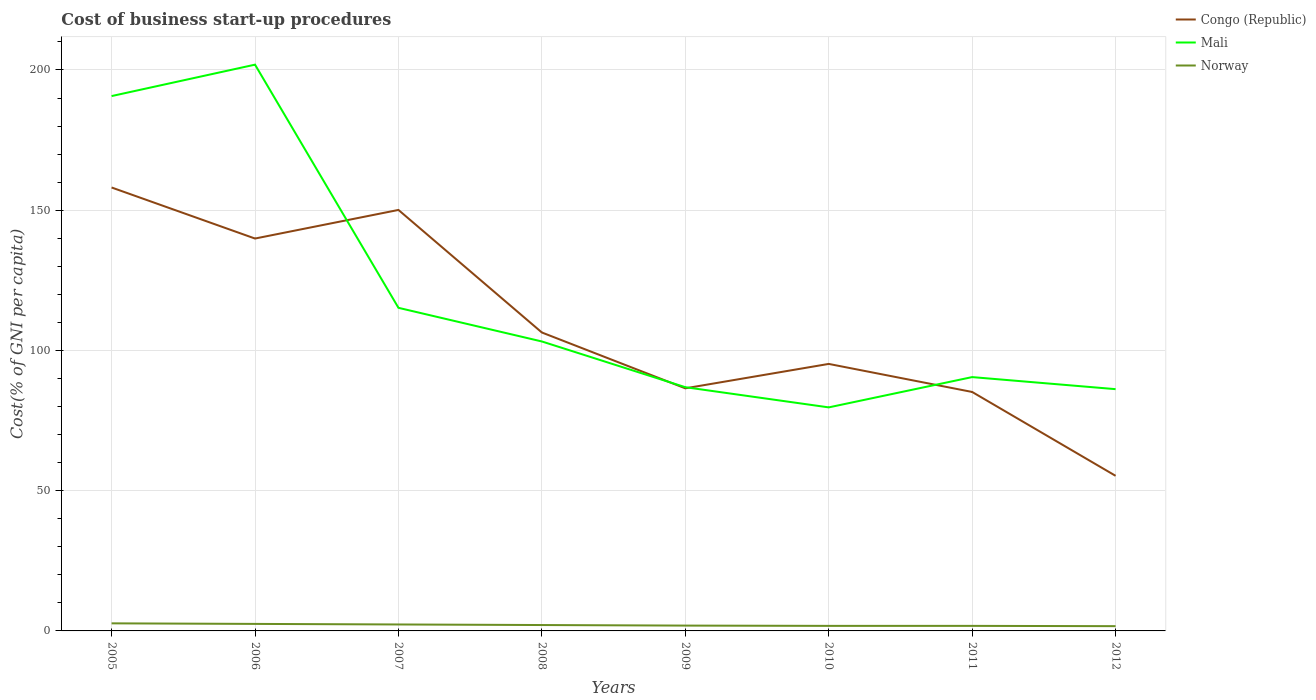Across all years, what is the maximum cost of business start-up procedures in Norway?
Provide a short and direct response. 1.7. In which year was the cost of business start-up procedures in Norway maximum?
Your answer should be very brief. 2012. What is the total cost of business start-up procedures in Mali in the graph?
Ensure brevity in your answer.  103.8. What is the difference between the highest and the second highest cost of business start-up procedures in Congo (Republic)?
Ensure brevity in your answer.  102.8. How many lines are there?
Keep it short and to the point. 3. Where does the legend appear in the graph?
Your answer should be compact. Top right. How are the legend labels stacked?
Provide a succinct answer. Vertical. What is the title of the graph?
Offer a very short reply. Cost of business start-up procedures. Does "Sao Tome and Principe" appear as one of the legend labels in the graph?
Ensure brevity in your answer.  No. What is the label or title of the X-axis?
Provide a short and direct response. Years. What is the label or title of the Y-axis?
Make the answer very short. Cost(% of GNI per capita). What is the Cost(% of GNI per capita) in Congo (Republic) in 2005?
Your response must be concise. 158.1. What is the Cost(% of GNI per capita) in Mali in 2005?
Your response must be concise. 190.7. What is the Cost(% of GNI per capita) of Norway in 2005?
Your answer should be very brief. 2.7. What is the Cost(% of GNI per capita) in Congo (Republic) in 2006?
Your answer should be compact. 139.9. What is the Cost(% of GNI per capita) of Mali in 2006?
Offer a very short reply. 201.9. What is the Cost(% of GNI per capita) of Norway in 2006?
Your response must be concise. 2.5. What is the Cost(% of GNI per capita) of Congo (Republic) in 2007?
Make the answer very short. 150.1. What is the Cost(% of GNI per capita) of Mali in 2007?
Make the answer very short. 115.2. What is the Cost(% of GNI per capita) in Norway in 2007?
Give a very brief answer. 2.3. What is the Cost(% of GNI per capita) in Congo (Republic) in 2008?
Your answer should be very brief. 106.4. What is the Cost(% of GNI per capita) in Mali in 2008?
Your answer should be compact. 103.2. What is the Cost(% of GNI per capita) of Norway in 2008?
Provide a succinct answer. 2.1. What is the Cost(% of GNI per capita) of Congo (Republic) in 2009?
Your response must be concise. 86.5. What is the Cost(% of GNI per capita) of Mali in 2009?
Provide a succinct answer. 86.9. What is the Cost(% of GNI per capita) of Congo (Republic) in 2010?
Your answer should be very brief. 95.2. What is the Cost(% of GNI per capita) of Mali in 2010?
Ensure brevity in your answer.  79.7. What is the Cost(% of GNI per capita) of Congo (Republic) in 2011?
Provide a succinct answer. 85.2. What is the Cost(% of GNI per capita) in Mali in 2011?
Provide a short and direct response. 90.5. What is the Cost(% of GNI per capita) of Congo (Republic) in 2012?
Keep it short and to the point. 55.3. What is the Cost(% of GNI per capita) of Mali in 2012?
Offer a very short reply. 86.2. What is the Cost(% of GNI per capita) of Norway in 2012?
Provide a short and direct response. 1.7. Across all years, what is the maximum Cost(% of GNI per capita) in Congo (Republic)?
Give a very brief answer. 158.1. Across all years, what is the maximum Cost(% of GNI per capita) in Mali?
Your response must be concise. 201.9. Across all years, what is the maximum Cost(% of GNI per capita) in Norway?
Provide a short and direct response. 2.7. Across all years, what is the minimum Cost(% of GNI per capita) in Congo (Republic)?
Provide a succinct answer. 55.3. Across all years, what is the minimum Cost(% of GNI per capita) in Mali?
Provide a short and direct response. 79.7. Across all years, what is the minimum Cost(% of GNI per capita) in Norway?
Provide a short and direct response. 1.7. What is the total Cost(% of GNI per capita) of Congo (Republic) in the graph?
Ensure brevity in your answer.  876.7. What is the total Cost(% of GNI per capita) of Mali in the graph?
Your answer should be very brief. 954.3. What is the total Cost(% of GNI per capita) of Norway in the graph?
Your response must be concise. 16.8. What is the difference between the Cost(% of GNI per capita) of Congo (Republic) in 2005 and that in 2006?
Offer a very short reply. 18.2. What is the difference between the Cost(% of GNI per capita) of Norway in 2005 and that in 2006?
Offer a very short reply. 0.2. What is the difference between the Cost(% of GNI per capita) in Congo (Republic) in 2005 and that in 2007?
Make the answer very short. 8. What is the difference between the Cost(% of GNI per capita) in Mali in 2005 and that in 2007?
Provide a succinct answer. 75.5. What is the difference between the Cost(% of GNI per capita) of Norway in 2005 and that in 2007?
Your answer should be very brief. 0.4. What is the difference between the Cost(% of GNI per capita) of Congo (Republic) in 2005 and that in 2008?
Keep it short and to the point. 51.7. What is the difference between the Cost(% of GNI per capita) of Mali in 2005 and that in 2008?
Your response must be concise. 87.5. What is the difference between the Cost(% of GNI per capita) of Congo (Republic) in 2005 and that in 2009?
Your answer should be compact. 71.6. What is the difference between the Cost(% of GNI per capita) in Mali in 2005 and that in 2009?
Offer a very short reply. 103.8. What is the difference between the Cost(% of GNI per capita) in Norway in 2005 and that in 2009?
Give a very brief answer. 0.8. What is the difference between the Cost(% of GNI per capita) in Congo (Republic) in 2005 and that in 2010?
Provide a succinct answer. 62.9. What is the difference between the Cost(% of GNI per capita) of Mali in 2005 and that in 2010?
Keep it short and to the point. 111. What is the difference between the Cost(% of GNI per capita) of Norway in 2005 and that in 2010?
Your response must be concise. 0.9. What is the difference between the Cost(% of GNI per capita) in Congo (Republic) in 2005 and that in 2011?
Your response must be concise. 72.9. What is the difference between the Cost(% of GNI per capita) of Mali in 2005 and that in 2011?
Provide a succinct answer. 100.2. What is the difference between the Cost(% of GNI per capita) of Congo (Republic) in 2005 and that in 2012?
Your answer should be very brief. 102.8. What is the difference between the Cost(% of GNI per capita) in Mali in 2005 and that in 2012?
Offer a very short reply. 104.5. What is the difference between the Cost(% of GNI per capita) of Mali in 2006 and that in 2007?
Your response must be concise. 86.7. What is the difference between the Cost(% of GNI per capita) of Norway in 2006 and that in 2007?
Offer a terse response. 0.2. What is the difference between the Cost(% of GNI per capita) of Congo (Republic) in 2006 and that in 2008?
Give a very brief answer. 33.5. What is the difference between the Cost(% of GNI per capita) of Mali in 2006 and that in 2008?
Your answer should be compact. 98.7. What is the difference between the Cost(% of GNI per capita) of Congo (Republic) in 2006 and that in 2009?
Your response must be concise. 53.4. What is the difference between the Cost(% of GNI per capita) in Mali in 2006 and that in 2009?
Give a very brief answer. 115. What is the difference between the Cost(% of GNI per capita) of Congo (Republic) in 2006 and that in 2010?
Offer a very short reply. 44.7. What is the difference between the Cost(% of GNI per capita) in Mali in 2006 and that in 2010?
Offer a very short reply. 122.2. What is the difference between the Cost(% of GNI per capita) in Norway in 2006 and that in 2010?
Offer a terse response. 0.7. What is the difference between the Cost(% of GNI per capita) in Congo (Republic) in 2006 and that in 2011?
Make the answer very short. 54.7. What is the difference between the Cost(% of GNI per capita) of Mali in 2006 and that in 2011?
Offer a very short reply. 111.4. What is the difference between the Cost(% of GNI per capita) in Congo (Republic) in 2006 and that in 2012?
Your response must be concise. 84.6. What is the difference between the Cost(% of GNI per capita) of Mali in 2006 and that in 2012?
Offer a terse response. 115.7. What is the difference between the Cost(% of GNI per capita) in Norway in 2006 and that in 2012?
Offer a very short reply. 0.8. What is the difference between the Cost(% of GNI per capita) in Congo (Republic) in 2007 and that in 2008?
Provide a short and direct response. 43.7. What is the difference between the Cost(% of GNI per capita) in Congo (Republic) in 2007 and that in 2009?
Your answer should be compact. 63.6. What is the difference between the Cost(% of GNI per capita) in Mali in 2007 and that in 2009?
Your answer should be compact. 28.3. What is the difference between the Cost(% of GNI per capita) of Norway in 2007 and that in 2009?
Ensure brevity in your answer.  0.4. What is the difference between the Cost(% of GNI per capita) in Congo (Republic) in 2007 and that in 2010?
Your response must be concise. 54.9. What is the difference between the Cost(% of GNI per capita) in Mali in 2007 and that in 2010?
Provide a short and direct response. 35.5. What is the difference between the Cost(% of GNI per capita) in Norway in 2007 and that in 2010?
Provide a succinct answer. 0.5. What is the difference between the Cost(% of GNI per capita) of Congo (Republic) in 2007 and that in 2011?
Your answer should be very brief. 64.9. What is the difference between the Cost(% of GNI per capita) in Mali in 2007 and that in 2011?
Ensure brevity in your answer.  24.7. What is the difference between the Cost(% of GNI per capita) in Congo (Republic) in 2007 and that in 2012?
Keep it short and to the point. 94.8. What is the difference between the Cost(% of GNI per capita) in Mali in 2007 and that in 2012?
Your answer should be compact. 29. What is the difference between the Cost(% of GNI per capita) of Mali in 2008 and that in 2009?
Your answer should be compact. 16.3. What is the difference between the Cost(% of GNI per capita) in Norway in 2008 and that in 2009?
Give a very brief answer. 0.2. What is the difference between the Cost(% of GNI per capita) in Congo (Republic) in 2008 and that in 2010?
Provide a succinct answer. 11.2. What is the difference between the Cost(% of GNI per capita) of Mali in 2008 and that in 2010?
Keep it short and to the point. 23.5. What is the difference between the Cost(% of GNI per capita) of Congo (Republic) in 2008 and that in 2011?
Offer a terse response. 21.2. What is the difference between the Cost(% of GNI per capita) of Mali in 2008 and that in 2011?
Your response must be concise. 12.7. What is the difference between the Cost(% of GNI per capita) in Norway in 2008 and that in 2011?
Give a very brief answer. 0.3. What is the difference between the Cost(% of GNI per capita) of Congo (Republic) in 2008 and that in 2012?
Offer a terse response. 51.1. What is the difference between the Cost(% of GNI per capita) of Norway in 2008 and that in 2012?
Offer a terse response. 0.4. What is the difference between the Cost(% of GNI per capita) of Mali in 2009 and that in 2010?
Make the answer very short. 7.2. What is the difference between the Cost(% of GNI per capita) of Congo (Republic) in 2009 and that in 2011?
Ensure brevity in your answer.  1.3. What is the difference between the Cost(% of GNI per capita) of Mali in 2009 and that in 2011?
Offer a very short reply. -3.6. What is the difference between the Cost(% of GNI per capita) in Norway in 2009 and that in 2011?
Your answer should be very brief. 0.1. What is the difference between the Cost(% of GNI per capita) in Congo (Republic) in 2009 and that in 2012?
Keep it short and to the point. 31.2. What is the difference between the Cost(% of GNI per capita) of Mali in 2009 and that in 2012?
Your answer should be very brief. 0.7. What is the difference between the Cost(% of GNI per capita) in Norway in 2009 and that in 2012?
Your answer should be very brief. 0.2. What is the difference between the Cost(% of GNI per capita) in Congo (Republic) in 2010 and that in 2011?
Keep it short and to the point. 10. What is the difference between the Cost(% of GNI per capita) in Norway in 2010 and that in 2011?
Ensure brevity in your answer.  0. What is the difference between the Cost(% of GNI per capita) in Congo (Republic) in 2010 and that in 2012?
Make the answer very short. 39.9. What is the difference between the Cost(% of GNI per capita) in Congo (Republic) in 2011 and that in 2012?
Keep it short and to the point. 29.9. What is the difference between the Cost(% of GNI per capita) of Mali in 2011 and that in 2012?
Ensure brevity in your answer.  4.3. What is the difference between the Cost(% of GNI per capita) of Norway in 2011 and that in 2012?
Your answer should be compact. 0.1. What is the difference between the Cost(% of GNI per capita) of Congo (Republic) in 2005 and the Cost(% of GNI per capita) of Mali in 2006?
Your response must be concise. -43.8. What is the difference between the Cost(% of GNI per capita) in Congo (Republic) in 2005 and the Cost(% of GNI per capita) in Norway in 2006?
Provide a short and direct response. 155.6. What is the difference between the Cost(% of GNI per capita) in Mali in 2005 and the Cost(% of GNI per capita) in Norway in 2006?
Provide a succinct answer. 188.2. What is the difference between the Cost(% of GNI per capita) in Congo (Republic) in 2005 and the Cost(% of GNI per capita) in Mali in 2007?
Make the answer very short. 42.9. What is the difference between the Cost(% of GNI per capita) in Congo (Republic) in 2005 and the Cost(% of GNI per capita) in Norway in 2007?
Offer a terse response. 155.8. What is the difference between the Cost(% of GNI per capita) of Mali in 2005 and the Cost(% of GNI per capita) of Norway in 2007?
Keep it short and to the point. 188.4. What is the difference between the Cost(% of GNI per capita) in Congo (Republic) in 2005 and the Cost(% of GNI per capita) in Mali in 2008?
Provide a succinct answer. 54.9. What is the difference between the Cost(% of GNI per capita) in Congo (Republic) in 2005 and the Cost(% of GNI per capita) in Norway in 2008?
Provide a succinct answer. 156. What is the difference between the Cost(% of GNI per capita) of Mali in 2005 and the Cost(% of GNI per capita) of Norway in 2008?
Ensure brevity in your answer.  188.6. What is the difference between the Cost(% of GNI per capita) in Congo (Republic) in 2005 and the Cost(% of GNI per capita) in Mali in 2009?
Make the answer very short. 71.2. What is the difference between the Cost(% of GNI per capita) in Congo (Republic) in 2005 and the Cost(% of GNI per capita) in Norway in 2009?
Make the answer very short. 156.2. What is the difference between the Cost(% of GNI per capita) in Mali in 2005 and the Cost(% of GNI per capita) in Norway in 2009?
Keep it short and to the point. 188.8. What is the difference between the Cost(% of GNI per capita) in Congo (Republic) in 2005 and the Cost(% of GNI per capita) in Mali in 2010?
Make the answer very short. 78.4. What is the difference between the Cost(% of GNI per capita) of Congo (Republic) in 2005 and the Cost(% of GNI per capita) of Norway in 2010?
Make the answer very short. 156.3. What is the difference between the Cost(% of GNI per capita) in Mali in 2005 and the Cost(% of GNI per capita) in Norway in 2010?
Provide a succinct answer. 188.9. What is the difference between the Cost(% of GNI per capita) in Congo (Republic) in 2005 and the Cost(% of GNI per capita) in Mali in 2011?
Offer a terse response. 67.6. What is the difference between the Cost(% of GNI per capita) in Congo (Republic) in 2005 and the Cost(% of GNI per capita) in Norway in 2011?
Provide a short and direct response. 156.3. What is the difference between the Cost(% of GNI per capita) in Mali in 2005 and the Cost(% of GNI per capita) in Norway in 2011?
Provide a short and direct response. 188.9. What is the difference between the Cost(% of GNI per capita) in Congo (Republic) in 2005 and the Cost(% of GNI per capita) in Mali in 2012?
Your answer should be very brief. 71.9. What is the difference between the Cost(% of GNI per capita) in Congo (Republic) in 2005 and the Cost(% of GNI per capita) in Norway in 2012?
Offer a very short reply. 156.4. What is the difference between the Cost(% of GNI per capita) of Mali in 2005 and the Cost(% of GNI per capita) of Norway in 2012?
Give a very brief answer. 189. What is the difference between the Cost(% of GNI per capita) of Congo (Republic) in 2006 and the Cost(% of GNI per capita) of Mali in 2007?
Your response must be concise. 24.7. What is the difference between the Cost(% of GNI per capita) in Congo (Republic) in 2006 and the Cost(% of GNI per capita) in Norway in 2007?
Keep it short and to the point. 137.6. What is the difference between the Cost(% of GNI per capita) in Mali in 2006 and the Cost(% of GNI per capita) in Norway in 2007?
Your response must be concise. 199.6. What is the difference between the Cost(% of GNI per capita) in Congo (Republic) in 2006 and the Cost(% of GNI per capita) in Mali in 2008?
Offer a terse response. 36.7. What is the difference between the Cost(% of GNI per capita) in Congo (Republic) in 2006 and the Cost(% of GNI per capita) in Norway in 2008?
Provide a short and direct response. 137.8. What is the difference between the Cost(% of GNI per capita) of Mali in 2006 and the Cost(% of GNI per capita) of Norway in 2008?
Ensure brevity in your answer.  199.8. What is the difference between the Cost(% of GNI per capita) of Congo (Republic) in 2006 and the Cost(% of GNI per capita) of Norway in 2009?
Your answer should be compact. 138. What is the difference between the Cost(% of GNI per capita) in Congo (Republic) in 2006 and the Cost(% of GNI per capita) in Mali in 2010?
Your answer should be very brief. 60.2. What is the difference between the Cost(% of GNI per capita) of Congo (Republic) in 2006 and the Cost(% of GNI per capita) of Norway in 2010?
Give a very brief answer. 138.1. What is the difference between the Cost(% of GNI per capita) of Mali in 2006 and the Cost(% of GNI per capita) of Norway in 2010?
Give a very brief answer. 200.1. What is the difference between the Cost(% of GNI per capita) in Congo (Republic) in 2006 and the Cost(% of GNI per capita) in Mali in 2011?
Your response must be concise. 49.4. What is the difference between the Cost(% of GNI per capita) in Congo (Republic) in 2006 and the Cost(% of GNI per capita) in Norway in 2011?
Offer a terse response. 138.1. What is the difference between the Cost(% of GNI per capita) of Mali in 2006 and the Cost(% of GNI per capita) of Norway in 2011?
Keep it short and to the point. 200.1. What is the difference between the Cost(% of GNI per capita) of Congo (Republic) in 2006 and the Cost(% of GNI per capita) of Mali in 2012?
Give a very brief answer. 53.7. What is the difference between the Cost(% of GNI per capita) of Congo (Republic) in 2006 and the Cost(% of GNI per capita) of Norway in 2012?
Offer a very short reply. 138.2. What is the difference between the Cost(% of GNI per capita) of Mali in 2006 and the Cost(% of GNI per capita) of Norway in 2012?
Offer a terse response. 200.2. What is the difference between the Cost(% of GNI per capita) of Congo (Republic) in 2007 and the Cost(% of GNI per capita) of Mali in 2008?
Ensure brevity in your answer.  46.9. What is the difference between the Cost(% of GNI per capita) of Congo (Republic) in 2007 and the Cost(% of GNI per capita) of Norway in 2008?
Offer a terse response. 148. What is the difference between the Cost(% of GNI per capita) in Mali in 2007 and the Cost(% of GNI per capita) in Norway in 2008?
Provide a succinct answer. 113.1. What is the difference between the Cost(% of GNI per capita) of Congo (Republic) in 2007 and the Cost(% of GNI per capita) of Mali in 2009?
Give a very brief answer. 63.2. What is the difference between the Cost(% of GNI per capita) in Congo (Republic) in 2007 and the Cost(% of GNI per capita) in Norway in 2009?
Offer a very short reply. 148.2. What is the difference between the Cost(% of GNI per capita) in Mali in 2007 and the Cost(% of GNI per capita) in Norway in 2009?
Your answer should be compact. 113.3. What is the difference between the Cost(% of GNI per capita) in Congo (Republic) in 2007 and the Cost(% of GNI per capita) in Mali in 2010?
Make the answer very short. 70.4. What is the difference between the Cost(% of GNI per capita) of Congo (Republic) in 2007 and the Cost(% of GNI per capita) of Norway in 2010?
Keep it short and to the point. 148.3. What is the difference between the Cost(% of GNI per capita) in Mali in 2007 and the Cost(% of GNI per capita) in Norway in 2010?
Provide a short and direct response. 113.4. What is the difference between the Cost(% of GNI per capita) of Congo (Republic) in 2007 and the Cost(% of GNI per capita) of Mali in 2011?
Your response must be concise. 59.6. What is the difference between the Cost(% of GNI per capita) in Congo (Republic) in 2007 and the Cost(% of GNI per capita) in Norway in 2011?
Ensure brevity in your answer.  148.3. What is the difference between the Cost(% of GNI per capita) of Mali in 2007 and the Cost(% of GNI per capita) of Norway in 2011?
Provide a succinct answer. 113.4. What is the difference between the Cost(% of GNI per capita) of Congo (Republic) in 2007 and the Cost(% of GNI per capita) of Mali in 2012?
Ensure brevity in your answer.  63.9. What is the difference between the Cost(% of GNI per capita) of Congo (Republic) in 2007 and the Cost(% of GNI per capita) of Norway in 2012?
Offer a very short reply. 148.4. What is the difference between the Cost(% of GNI per capita) of Mali in 2007 and the Cost(% of GNI per capita) of Norway in 2012?
Ensure brevity in your answer.  113.5. What is the difference between the Cost(% of GNI per capita) in Congo (Republic) in 2008 and the Cost(% of GNI per capita) in Norway in 2009?
Provide a succinct answer. 104.5. What is the difference between the Cost(% of GNI per capita) in Mali in 2008 and the Cost(% of GNI per capita) in Norway in 2009?
Your answer should be compact. 101.3. What is the difference between the Cost(% of GNI per capita) in Congo (Republic) in 2008 and the Cost(% of GNI per capita) in Mali in 2010?
Make the answer very short. 26.7. What is the difference between the Cost(% of GNI per capita) in Congo (Republic) in 2008 and the Cost(% of GNI per capita) in Norway in 2010?
Offer a very short reply. 104.6. What is the difference between the Cost(% of GNI per capita) in Mali in 2008 and the Cost(% of GNI per capita) in Norway in 2010?
Give a very brief answer. 101.4. What is the difference between the Cost(% of GNI per capita) in Congo (Republic) in 2008 and the Cost(% of GNI per capita) in Norway in 2011?
Offer a very short reply. 104.6. What is the difference between the Cost(% of GNI per capita) in Mali in 2008 and the Cost(% of GNI per capita) in Norway in 2011?
Make the answer very short. 101.4. What is the difference between the Cost(% of GNI per capita) in Congo (Republic) in 2008 and the Cost(% of GNI per capita) in Mali in 2012?
Provide a succinct answer. 20.2. What is the difference between the Cost(% of GNI per capita) of Congo (Republic) in 2008 and the Cost(% of GNI per capita) of Norway in 2012?
Make the answer very short. 104.7. What is the difference between the Cost(% of GNI per capita) of Mali in 2008 and the Cost(% of GNI per capita) of Norway in 2012?
Offer a terse response. 101.5. What is the difference between the Cost(% of GNI per capita) in Congo (Republic) in 2009 and the Cost(% of GNI per capita) in Norway in 2010?
Your response must be concise. 84.7. What is the difference between the Cost(% of GNI per capita) in Mali in 2009 and the Cost(% of GNI per capita) in Norway in 2010?
Your answer should be compact. 85.1. What is the difference between the Cost(% of GNI per capita) in Congo (Republic) in 2009 and the Cost(% of GNI per capita) in Norway in 2011?
Provide a short and direct response. 84.7. What is the difference between the Cost(% of GNI per capita) of Mali in 2009 and the Cost(% of GNI per capita) of Norway in 2011?
Offer a terse response. 85.1. What is the difference between the Cost(% of GNI per capita) in Congo (Republic) in 2009 and the Cost(% of GNI per capita) in Norway in 2012?
Offer a very short reply. 84.8. What is the difference between the Cost(% of GNI per capita) of Mali in 2009 and the Cost(% of GNI per capita) of Norway in 2012?
Give a very brief answer. 85.2. What is the difference between the Cost(% of GNI per capita) in Congo (Republic) in 2010 and the Cost(% of GNI per capita) in Norway in 2011?
Offer a terse response. 93.4. What is the difference between the Cost(% of GNI per capita) of Mali in 2010 and the Cost(% of GNI per capita) of Norway in 2011?
Provide a short and direct response. 77.9. What is the difference between the Cost(% of GNI per capita) of Congo (Republic) in 2010 and the Cost(% of GNI per capita) of Norway in 2012?
Provide a succinct answer. 93.5. What is the difference between the Cost(% of GNI per capita) in Congo (Republic) in 2011 and the Cost(% of GNI per capita) in Norway in 2012?
Provide a succinct answer. 83.5. What is the difference between the Cost(% of GNI per capita) of Mali in 2011 and the Cost(% of GNI per capita) of Norway in 2012?
Your response must be concise. 88.8. What is the average Cost(% of GNI per capita) in Congo (Republic) per year?
Your response must be concise. 109.59. What is the average Cost(% of GNI per capita) in Mali per year?
Offer a terse response. 119.29. In the year 2005, what is the difference between the Cost(% of GNI per capita) of Congo (Republic) and Cost(% of GNI per capita) of Mali?
Your answer should be compact. -32.6. In the year 2005, what is the difference between the Cost(% of GNI per capita) of Congo (Republic) and Cost(% of GNI per capita) of Norway?
Make the answer very short. 155.4. In the year 2005, what is the difference between the Cost(% of GNI per capita) of Mali and Cost(% of GNI per capita) of Norway?
Keep it short and to the point. 188. In the year 2006, what is the difference between the Cost(% of GNI per capita) in Congo (Republic) and Cost(% of GNI per capita) in Mali?
Keep it short and to the point. -62. In the year 2006, what is the difference between the Cost(% of GNI per capita) in Congo (Republic) and Cost(% of GNI per capita) in Norway?
Give a very brief answer. 137.4. In the year 2006, what is the difference between the Cost(% of GNI per capita) of Mali and Cost(% of GNI per capita) of Norway?
Give a very brief answer. 199.4. In the year 2007, what is the difference between the Cost(% of GNI per capita) in Congo (Republic) and Cost(% of GNI per capita) in Mali?
Keep it short and to the point. 34.9. In the year 2007, what is the difference between the Cost(% of GNI per capita) in Congo (Republic) and Cost(% of GNI per capita) in Norway?
Your answer should be very brief. 147.8. In the year 2007, what is the difference between the Cost(% of GNI per capita) in Mali and Cost(% of GNI per capita) in Norway?
Your answer should be very brief. 112.9. In the year 2008, what is the difference between the Cost(% of GNI per capita) of Congo (Republic) and Cost(% of GNI per capita) of Mali?
Your response must be concise. 3.2. In the year 2008, what is the difference between the Cost(% of GNI per capita) of Congo (Republic) and Cost(% of GNI per capita) of Norway?
Provide a short and direct response. 104.3. In the year 2008, what is the difference between the Cost(% of GNI per capita) in Mali and Cost(% of GNI per capita) in Norway?
Keep it short and to the point. 101.1. In the year 2009, what is the difference between the Cost(% of GNI per capita) in Congo (Republic) and Cost(% of GNI per capita) in Norway?
Provide a short and direct response. 84.6. In the year 2010, what is the difference between the Cost(% of GNI per capita) in Congo (Republic) and Cost(% of GNI per capita) in Norway?
Your answer should be compact. 93.4. In the year 2010, what is the difference between the Cost(% of GNI per capita) of Mali and Cost(% of GNI per capita) of Norway?
Provide a short and direct response. 77.9. In the year 2011, what is the difference between the Cost(% of GNI per capita) in Congo (Republic) and Cost(% of GNI per capita) in Norway?
Provide a succinct answer. 83.4. In the year 2011, what is the difference between the Cost(% of GNI per capita) in Mali and Cost(% of GNI per capita) in Norway?
Offer a terse response. 88.7. In the year 2012, what is the difference between the Cost(% of GNI per capita) in Congo (Republic) and Cost(% of GNI per capita) in Mali?
Make the answer very short. -30.9. In the year 2012, what is the difference between the Cost(% of GNI per capita) in Congo (Republic) and Cost(% of GNI per capita) in Norway?
Keep it short and to the point. 53.6. In the year 2012, what is the difference between the Cost(% of GNI per capita) of Mali and Cost(% of GNI per capita) of Norway?
Make the answer very short. 84.5. What is the ratio of the Cost(% of GNI per capita) in Congo (Republic) in 2005 to that in 2006?
Your answer should be very brief. 1.13. What is the ratio of the Cost(% of GNI per capita) in Mali in 2005 to that in 2006?
Your answer should be compact. 0.94. What is the ratio of the Cost(% of GNI per capita) of Congo (Republic) in 2005 to that in 2007?
Your answer should be very brief. 1.05. What is the ratio of the Cost(% of GNI per capita) of Mali in 2005 to that in 2007?
Keep it short and to the point. 1.66. What is the ratio of the Cost(% of GNI per capita) in Norway in 2005 to that in 2007?
Your answer should be very brief. 1.17. What is the ratio of the Cost(% of GNI per capita) of Congo (Republic) in 2005 to that in 2008?
Make the answer very short. 1.49. What is the ratio of the Cost(% of GNI per capita) of Mali in 2005 to that in 2008?
Keep it short and to the point. 1.85. What is the ratio of the Cost(% of GNI per capita) of Congo (Republic) in 2005 to that in 2009?
Provide a succinct answer. 1.83. What is the ratio of the Cost(% of GNI per capita) of Mali in 2005 to that in 2009?
Provide a succinct answer. 2.19. What is the ratio of the Cost(% of GNI per capita) of Norway in 2005 to that in 2009?
Offer a terse response. 1.42. What is the ratio of the Cost(% of GNI per capita) in Congo (Republic) in 2005 to that in 2010?
Provide a short and direct response. 1.66. What is the ratio of the Cost(% of GNI per capita) in Mali in 2005 to that in 2010?
Offer a terse response. 2.39. What is the ratio of the Cost(% of GNI per capita) of Congo (Republic) in 2005 to that in 2011?
Provide a succinct answer. 1.86. What is the ratio of the Cost(% of GNI per capita) in Mali in 2005 to that in 2011?
Offer a very short reply. 2.11. What is the ratio of the Cost(% of GNI per capita) of Norway in 2005 to that in 2011?
Make the answer very short. 1.5. What is the ratio of the Cost(% of GNI per capita) in Congo (Republic) in 2005 to that in 2012?
Offer a very short reply. 2.86. What is the ratio of the Cost(% of GNI per capita) in Mali in 2005 to that in 2012?
Keep it short and to the point. 2.21. What is the ratio of the Cost(% of GNI per capita) in Norway in 2005 to that in 2012?
Make the answer very short. 1.59. What is the ratio of the Cost(% of GNI per capita) of Congo (Republic) in 2006 to that in 2007?
Keep it short and to the point. 0.93. What is the ratio of the Cost(% of GNI per capita) of Mali in 2006 to that in 2007?
Ensure brevity in your answer.  1.75. What is the ratio of the Cost(% of GNI per capita) in Norway in 2006 to that in 2007?
Your answer should be very brief. 1.09. What is the ratio of the Cost(% of GNI per capita) in Congo (Republic) in 2006 to that in 2008?
Keep it short and to the point. 1.31. What is the ratio of the Cost(% of GNI per capita) of Mali in 2006 to that in 2008?
Ensure brevity in your answer.  1.96. What is the ratio of the Cost(% of GNI per capita) of Norway in 2006 to that in 2008?
Keep it short and to the point. 1.19. What is the ratio of the Cost(% of GNI per capita) in Congo (Republic) in 2006 to that in 2009?
Make the answer very short. 1.62. What is the ratio of the Cost(% of GNI per capita) of Mali in 2006 to that in 2009?
Your answer should be very brief. 2.32. What is the ratio of the Cost(% of GNI per capita) of Norway in 2006 to that in 2009?
Provide a succinct answer. 1.32. What is the ratio of the Cost(% of GNI per capita) of Congo (Republic) in 2006 to that in 2010?
Offer a very short reply. 1.47. What is the ratio of the Cost(% of GNI per capita) in Mali in 2006 to that in 2010?
Your answer should be very brief. 2.53. What is the ratio of the Cost(% of GNI per capita) of Norway in 2006 to that in 2010?
Give a very brief answer. 1.39. What is the ratio of the Cost(% of GNI per capita) in Congo (Republic) in 2006 to that in 2011?
Keep it short and to the point. 1.64. What is the ratio of the Cost(% of GNI per capita) of Mali in 2006 to that in 2011?
Your answer should be compact. 2.23. What is the ratio of the Cost(% of GNI per capita) of Norway in 2006 to that in 2011?
Offer a terse response. 1.39. What is the ratio of the Cost(% of GNI per capita) in Congo (Republic) in 2006 to that in 2012?
Make the answer very short. 2.53. What is the ratio of the Cost(% of GNI per capita) of Mali in 2006 to that in 2012?
Your response must be concise. 2.34. What is the ratio of the Cost(% of GNI per capita) in Norway in 2006 to that in 2012?
Provide a short and direct response. 1.47. What is the ratio of the Cost(% of GNI per capita) of Congo (Republic) in 2007 to that in 2008?
Give a very brief answer. 1.41. What is the ratio of the Cost(% of GNI per capita) of Mali in 2007 to that in 2008?
Offer a terse response. 1.12. What is the ratio of the Cost(% of GNI per capita) of Norway in 2007 to that in 2008?
Your answer should be compact. 1.1. What is the ratio of the Cost(% of GNI per capita) of Congo (Republic) in 2007 to that in 2009?
Provide a short and direct response. 1.74. What is the ratio of the Cost(% of GNI per capita) in Mali in 2007 to that in 2009?
Your response must be concise. 1.33. What is the ratio of the Cost(% of GNI per capita) of Norway in 2007 to that in 2009?
Give a very brief answer. 1.21. What is the ratio of the Cost(% of GNI per capita) of Congo (Republic) in 2007 to that in 2010?
Ensure brevity in your answer.  1.58. What is the ratio of the Cost(% of GNI per capita) of Mali in 2007 to that in 2010?
Your answer should be compact. 1.45. What is the ratio of the Cost(% of GNI per capita) of Norway in 2007 to that in 2010?
Offer a terse response. 1.28. What is the ratio of the Cost(% of GNI per capita) of Congo (Republic) in 2007 to that in 2011?
Keep it short and to the point. 1.76. What is the ratio of the Cost(% of GNI per capita) of Mali in 2007 to that in 2011?
Ensure brevity in your answer.  1.27. What is the ratio of the Cost(% of GNI per capita) in Norway in 2007 to that in 2011?
Your answer should be compact. 1.28. What is the ratio of the Cost(% of GNI per capita) in Congo (Republic) in 2007 to that in 2012?
Your response must be concise. 2.71. What is the ratio of the Cost(% of GNI per capita) of Mali in 2007 to that in 2012?
Ensure brevity in your answer.  1.34. What is the ratio of the Cost(% of GNI per capita) of Norway in 2007 to that in 2012?
Make the answer very short. 1.35. What is the ratio of the Cost(% of GNI per capita) of Congo (Republic) in 2008 to that in 2009?
Ensure brevity in your answer.  1.23. What is the ratio of the Cost(% of GNI per capita) in Mali in 2008 to that in 2009?
Offer a very short reply. 1.19. What is the ratio of the Cost(% of GNI per capita) in Norway in 2008 to that in 2009?
Your response must be concise. 1.11. What is the ratio of the Cost(% of GNI per capita) in Congo (Republic) in 2008 to that in 2010?
Your answer should be compact. 1.12. What is the ratio of the Cost(% of GNI per capita) of Mali in 2008 to that in 2010?
Offer a terse response. 1.29. What is the ratio of the Cost(% of GNI per capita) of Congo (Republic) in 2008 to that in 2011?
Give a very brief answer. 1.25. What is the ratio of the Cost(% of GNI per capita) in Mali in 2008 to that in 2011?
Your answer should be very brief. 1.14. What is the ratio of the Cost(% of GNI per capita) in Congo (Republic) in 2008 to that in 2012?
Offer a terse response. 1.92. What is the ratio of the Cost(% of GNI per capita) of Mali in 2008 to that in 2012?
Give a very brief answer. 1.2. What is the ratio of the Cost(% of GNI per capita) in Norway in 2008 to that in 2012?
Offer a terse response. 1.24. What is the ratio of the Cost(% of GNI per capita) of Congo (Republic) in 2009 to that in 2010?
Offer a terse response. 0.91. What is the ratio of the Cost(% of GNI per capita) of Mali in 2009 to that in 2010?
Make the answer very short. 1.09. What is the ratio of the Cost(% of GNI per capita) of Norway in 2009 to that in 2010?
Give a very brief answer. 1.06. What is the ratio of the Cost(% of GNI per capita) in Congo (Republic) in 2009 to that in 2011?
Keep it short and to the point. 1.02. What is the ratio of the Cost(% of GNI per capita) of Mali in 2009 to that in 2011?
Offer a very short reply. 0.96. What is the ratio of the Cost(% of GNI per capita) in Norway in 2009 to that in 2011?
Offer a very short reply. 1.06. What is the ratio of the Cost(% of GNI per capita) in Congo (Republic) in 2009 to that in 2012?
Your answer should be compact. 1.56. What is the ratio of the Cost(% of GNI per capita) in Mali in 2009 to that in 2012?
Your answer should be compact. 1.01. What is the ratio of the Cost(% of GNI per capita) in Norway in 2009 to that in 2012?
Offer a terse response. 1.12. What is the ratio of the Cost(% of GNI per capita) of Congo (Republic) in 2010 to that in 2011?
Provide a succinct answer. 1.12. What is the ratio of the Cost(% of GNI per capita) of Mali in 2010 to that in 2011?
Give a very brief answer. 0.88. What is the ratio of the Cost(% of GNI per capita) of Congo (Republic) in 2010 to that in 2012?
Offer a very short reply. 1.72. What is the ratio of the Cost(% of GNI per capita) of Mali in 2010 to that in 2012?
Your response must be concise. 0.92. What is the ratio of the Cost(% of GNI per capita) in Norway in 2010 to that in 2012?
Your response must be concise. 1.06. What is the ratio of the Cost(% of GNI per capita) of Congo (Republic) in 2011 to that in 2012?
Offer a terse response. 1.54. What is the ratio of the Cost(% of GNI per capita) of Mali in 2011 to that in 2012?
Make the answer very short. 1.05. What is the ratio of the Cost(% of GNI per capita) of Norway in 2011 to that in 2012?
Offer a very short reply. 1.06. What is the difference between the highest and the second highest Cost(% of GNI per capita) of Mali?
Give a very brief answer. 11.2. What is the difference between the highest and the lowest Cost(% of GNI per capita) in Congo (Republic)?
Offer a very short reply. 102.8. What is the difference between the highest and the lowest Cost(% of GNI per capita) of Mali?
Provide a short and direct response. 122.2. What is the difference between the highest and the lowest Cost(% of GNI per capita) of Norway?
Provide a succinct answer. 1. 